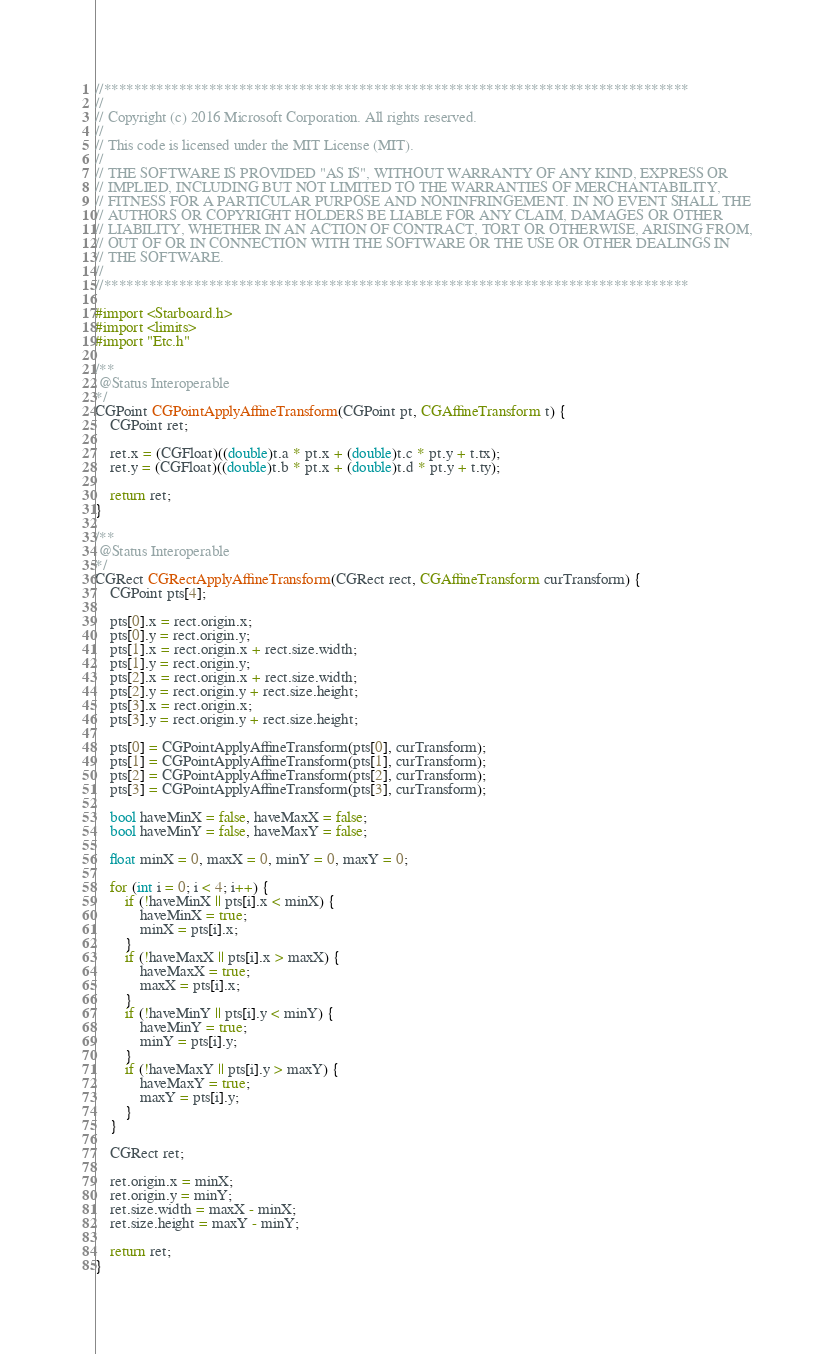Convert code to text. <code><loc_0><loc_0><loc_500><loc_500><_ObjectiveC_>//******************************************************************************
//
// Copyright (c) 2016 Microsoft Corporation. All rights reserved.
//
// This code is licensed under the MIT License (MIT).
//
// THE SOFTWARE IS PROVIDED "AS IS", WITHOUT WARRANTY OF ANY KIND, EXPRESS OR
// IMPLIED, INCLUDING BUT NOT LIMITED TO THE WARRANTIES OF MERCHANTABILITY,
// FITNESS FOR A PARTICULAR PURPOSE AND NONINFRINGEMENT. IN NO EVENT SHALL THE
// AUTHORS OR COPYRIGHT HOLDERS BE LIABLE FOR ANY CLAIM, DAMAGES OR OTHER
// LIABILITY, WHETHER IN AN ACTION OF CONTRACT, TORT OR OTHERWISE, ARISING FROM,
// OUT OF OR IN CONNECTION WITH THE SOFTWARE OR THE USE OR OTHER DEALINGS IN
// THE SOFTWARE.
//
//******************************************************************************

#import <Starboard.h>
#import <limits>
#import "Etc.h"

/**
 @Status Interoperable
*/
CGPoint CGPointApplyAffineTransform(CGPoint pt, CGAffineTransform t) {
    CGPoint ret;

    ret.x = (CGFloat)((double)t.a * pt.x + (double)t.c * pt.y + t.tx);
    ret.y = (CGFloat)((double)t.b * pt.x + (double)t.d * pt.y + t.ty);

    return ret;
}

/**
 @Status Interoperable
*/
CGRect CGRectApplyAffineTransform(CGRect rect, CGAffineTransform curTransform) {
    CGPoint pts[4];

    pts[0].x = rect.origin.x;
    pts[0].y = rect.origin.y;
    pts[1].x = rect.origin.x + rect.size.width;
    pts[1].y = rect.origin.y;
    pts[2].x = rect.origin.x + rect.size.width;
    pts[2].y = rect.origin.y + rect.size.height;
    pts[3].x = rect.origin.x;
    pts[3].y = rect.origin.y + rect.size.height;

    pts[0] = CGPointApplyAffineTransform(pts[0], curTransform);
    pts[1] = CGPointApplyAffineTransform(pts[1], curTransform);
    pts[2] = CGPointApplyAffineTransform(pts[2], curTransform);
    pts[3] = CGPointApplyAffineTransform(pts[3], curTransform);

    bool haveMinX = false, haveMaxX = false;
    bool haveMinY = false, haveMaxY = false;

    float minX = 0, maxX = 0, minY = 0, maxY = 0;

    for (int i = 0; i < 4; i++) {
        if (!haveMinX || pts[i].x < minX) {
            haveMinX = true;
            minX = pts[i].x;
        }
        if (!haveMaxX || pts[i].x > maxX) {
            haveMaxX = true;
            maxX = pts[i].x;
        }
        if (!haveMinY || pts[i].y < minY) {
            haveMinY = true;
            minY = pts[i].y;
        }
        if (!haveMaxY || pts[i].y > maxY) {
            haveMaxY = true;
            maxY = pts[i].y;
        }
    }

    CGRect ret;

    ret.origin.x = minX;
    ret.origin.y = minY;
    ret.size.width = maxX - minX;
    ret.size.height = maxY - minY;

    return ret;
}
</code> 